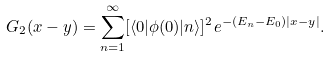<formula> <loc_0><loc_0><loc_500><loc_500>G _ { 2 } ( x - y ) = \sum _ { n = 1 } ^ { \infty } [ \langle 0 | \phi ( 0 ) | n \rangle ] ^ { 2 } e ^ { - ( E _ { n } - E _ { 0 } ) | x - y | } .</formula> 